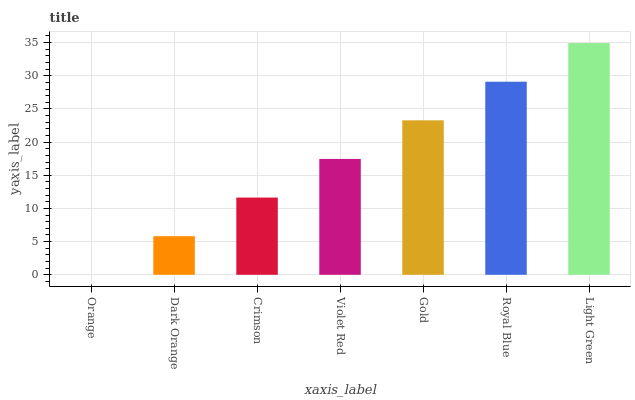Is Orange the minimum?
Answer yes or no. Yes. Is Light Green the maximum?
Answer yes or no. Yes. Is Dark Orange the minimum?
Answer yes or no. No. Is Dark Orange the maximum?
Answer yes or no. No. Is Dark Orange greater than Orange?
Answer yes or no. Yes. Is Orange less than Dark Orange?
Answer yes or no. Yes. Is Orange greater than Dark Orange?
Answer yes or no. No. Is Dark Orange less than Orange?
Answer yes or no. No. Is Violet Red the high median?
Answer yes or no. Yes. Is Violet Red the low median?
Answer yes or no. Yes. Is Dark Orange the high median?
Answer yes or no. No. Is Dark Orange the low median?
Answer yes or no. No. 